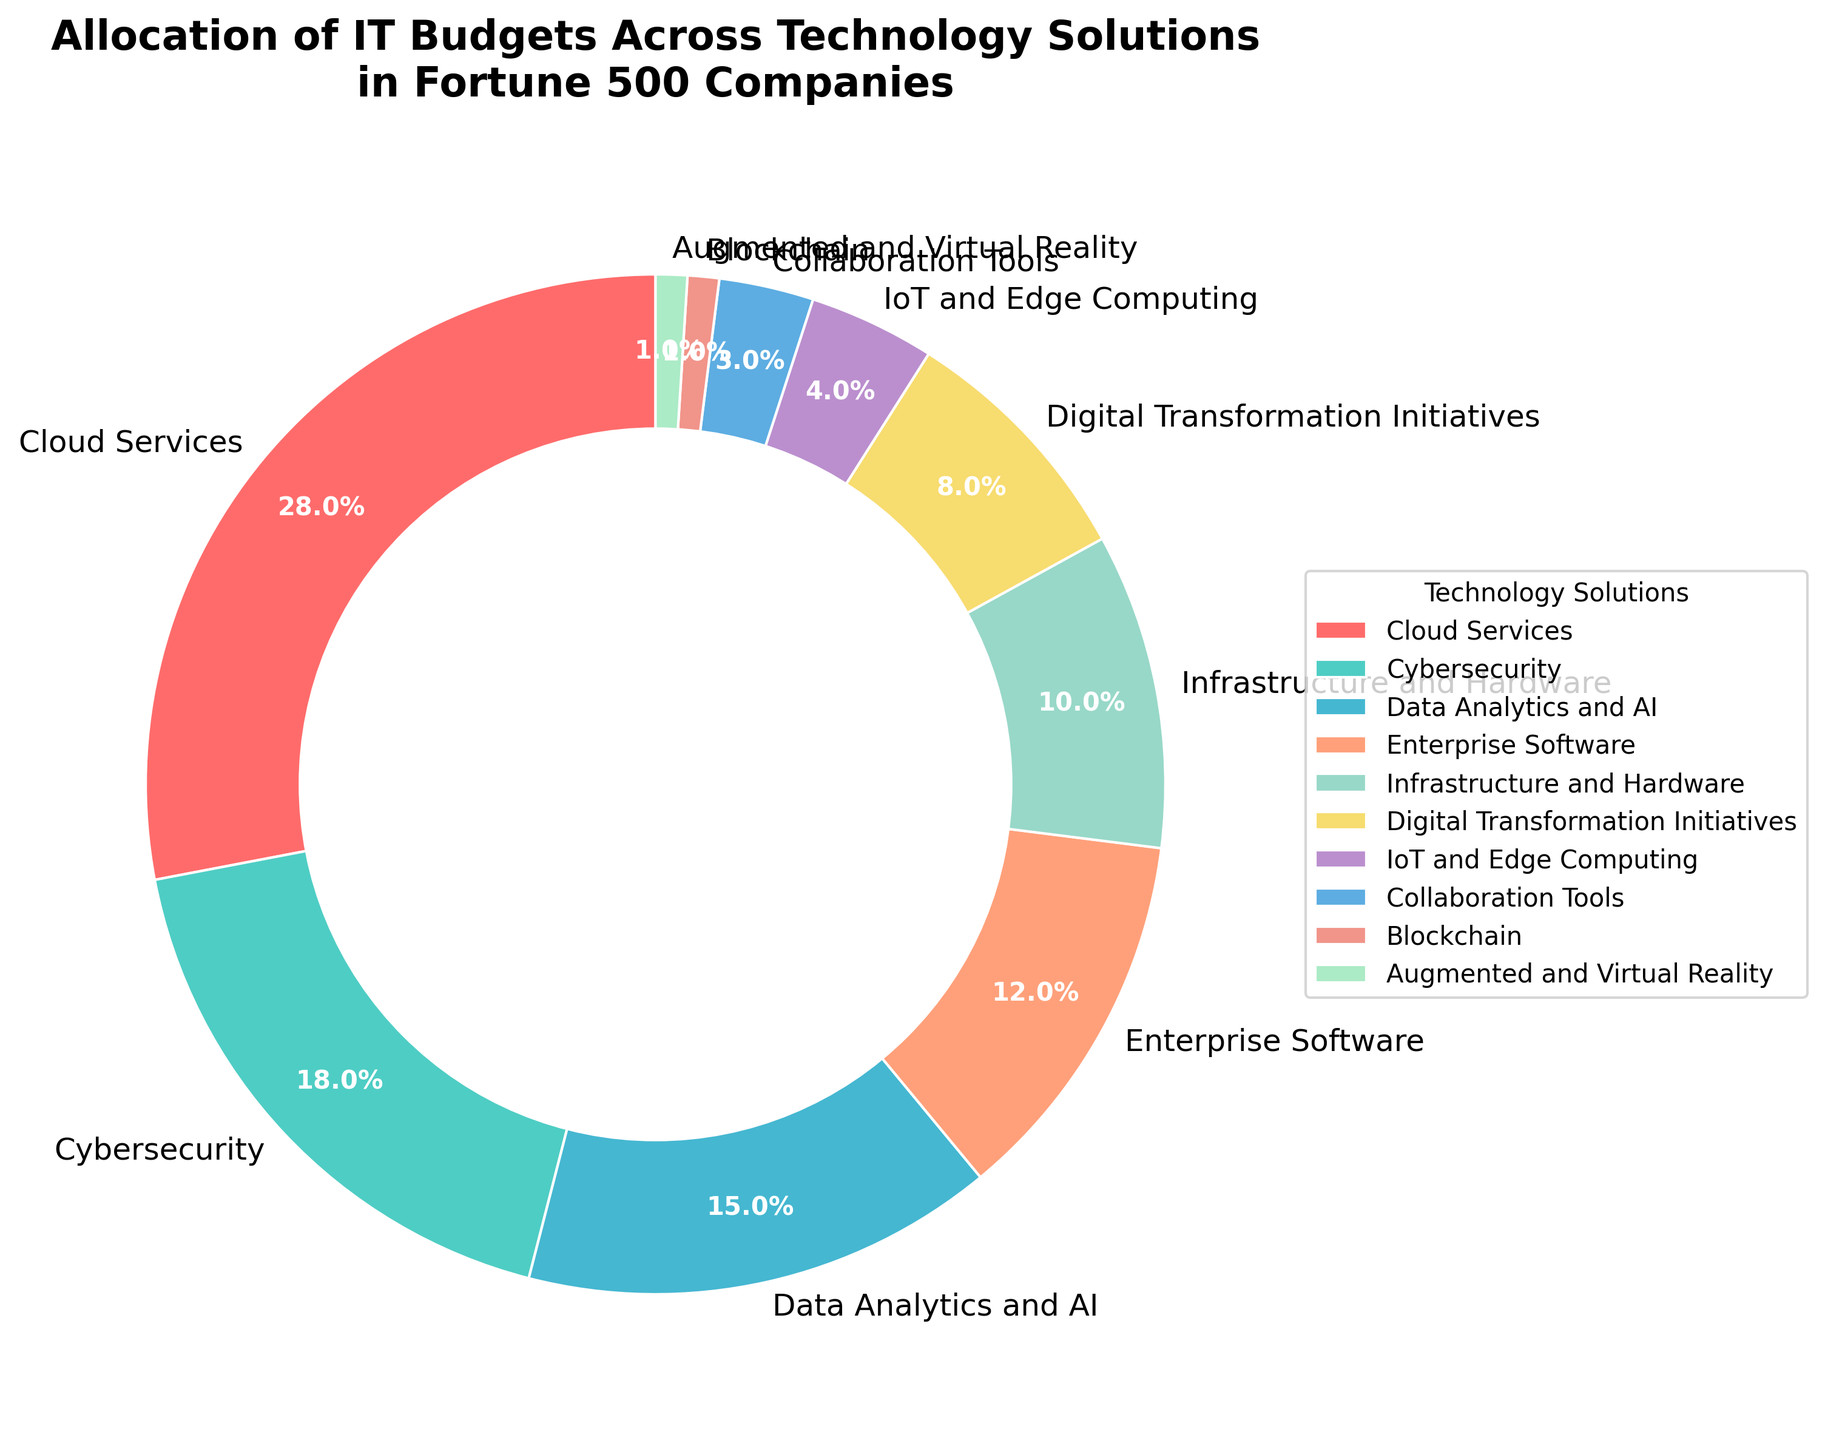What percentage of the IT budget is allocated to both Cloud Services and Cybersecurity combined? Sum the percentages for Cloud Services (28%) and Cybersecurity (18%). 28% + 18% = 46%.
Answer: 46% Which technology solution has the smallest allocation of IT budget, and what is its percentage? The smallest allocation is seen for Blockchain and Augmented and Virtual Reality, both at 1%.
Answer: Blockchain and Augmented and Virtual Reality, 1% Is the percentage allocation for Data Analytics and AI greater than that for Enterprise Software and Digital Transformation Initiatives combined? Data Analytics and AI is 15%. The combined allocation for Enterprise Software (12%) and Digital Transformation Initiatives (8%) is 12% + 8% = 20%, which is greater.
Answer: No What is the difference in budget allocation between Infrastructure and Hardware and IoT and Edge Computing? Subtract the percentage for IoT and Edge Computing (4%) from Infrastructure and Hardware (10%). 10% - 4% = 6%.
Answer: 6% Among the technology solutions, which three have the largest allocations, and what are their percentages? The three largest allocations are Cloud Services (28%), Cybersecurity (18%), and Data Analytics and AI (15%).
Answer: Cloud Services (28%), Cybersecurity (18%), Data Analytics and AI (15%) How much more is allocated to Cloud Services compared to Digital Transformation Initiatives? Subtract the percentage for Digital Transformation Initiatives (8%) from Cloud Services (28%). 28% - 8% = 20%.
Answer: 20% What is the combined percentage of budget allocation for Infrastructure and Hardware, Collaboration Tools, and Augmented and Virtual Reality? Sum the percentages for Infrastructure and Hardware (10%), Collaboration Tools (3%), and Augmented and Virtual Reality (1%). 10% + 3% + 1% = 14%.
Answer: 14% Is the budget allocation for Cybersecurity closer to Cloud Services or Data Analytics and AI? The difference between Cybersecurity (18%) and Cloud Services (28%) is 10%. The difference between Cybersecurity (18%) and Data Analytics and AI (15%) is 3%.
Answer: Data Analytics and AI 